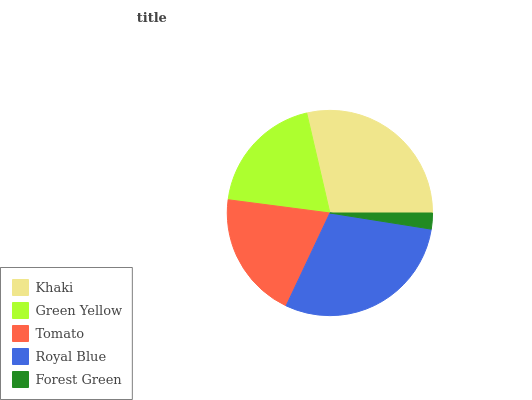Is Forest Green the minimum?
Answer yes or no. Yes. Is Royal Blue the maximum?
Answer yes or no. Yes. Is Green Yellow the minimum?
Answer yes or no. No. Is Green Yellow the maximum?
Answer yes or no. No. Is Khaki greater than Green Yellow?
Answer yes or no. Yes. Is Green Yellow less than Khaki?
Answer yes or no. Yes. Is Green Yellow greater than Khaki?
Answer yes or no. No. Is Khaki less than Green Yellow?
Answer yes or no. No. Is Tomato the high median?
Answer yes or no. Yes. Is Tomato the low median?
Answer yes or no. Yes. Is Forest Green the high median?
Answer yes or no. No. Is Khaki the low median?
Answer yes or no. No. 